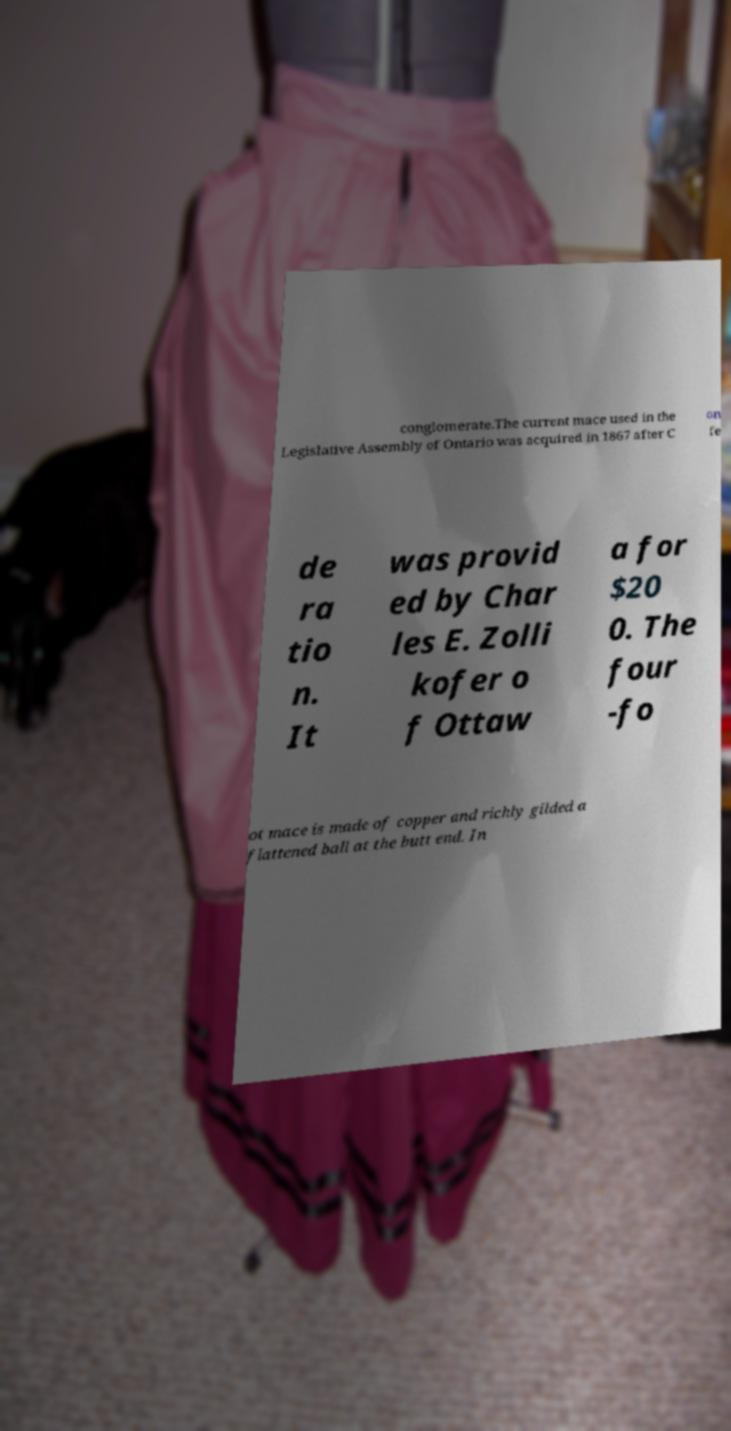Please identify and transcribe the text found in this image. conglomerate.The current mace used in the Legislative Assembly of Ontario was acquired in 1867 after C on fe de ra tio n. It was provid ed by Char les E. Zolli kofer o f Ottaw a for $20 0. The four -fo ot mace is made of copper and richly gilded a flattened ball at the butt end. In 